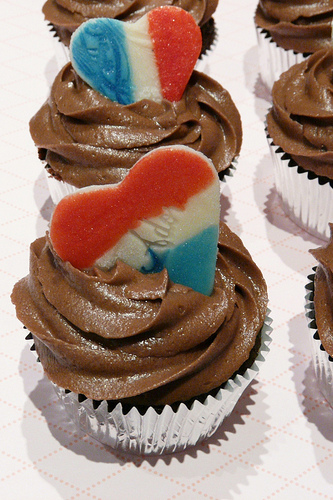<image>
Is there a cookie to the left of the frosting? No. The cookie is not to the left of the frosting. From this viewpoint, they have a different horizontal relationship. 